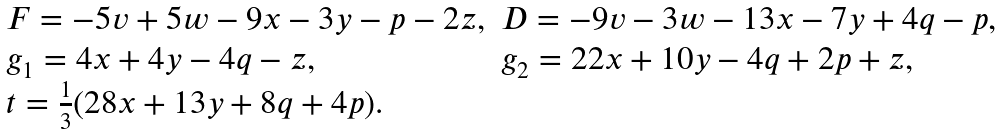Convert formula to latex. <formula><loc_0><loc_0><loc_500><loc_500>\begin{array} { l l } F = - 5 v + 5 w - 9 x - 3 y - p - 2 z , & D = - 9 v - 3 w - 1 3 x - 7 y + 4 q - p , \\ g _ { 1 } = 4 x + 4 y - 4 q - z , & g _ { 2 } = 2 2 x + 1 0 y - 4 q + 2 p + z , \\ t = \frac { 1 } { 3 } ( 2 8 x + 1 3 y + 8 q + 4 p ) . \end{array}</formula> 